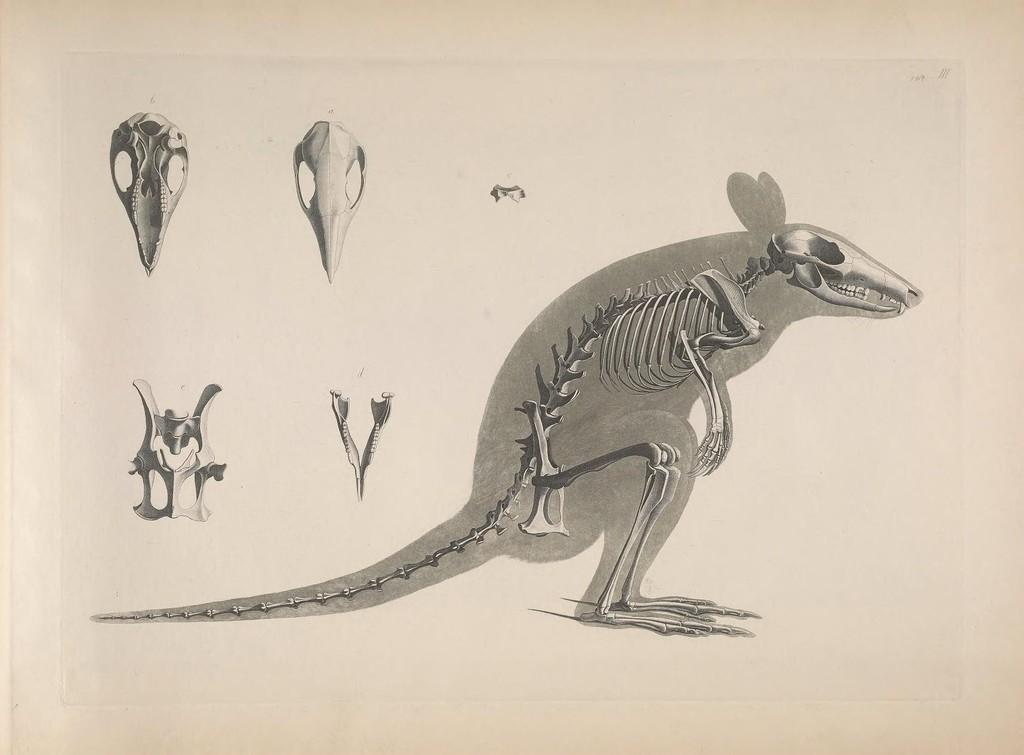What is the medium of the image? The image is a drawing on a white paper. What type of subject is depicted in the drawing? There is an animal depicted in the drawing. Can you describe any specific features of the animal in the drawing? There are parts of the animal visible in the drawing. What type of cart is being pulled by the animal in the drawing? There is no cart present in the drawing; it only depicts an animal. How many pages are there in the drawing? The drawing is on a single sheet of white paper, so there is only one page. 